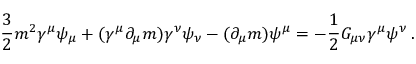<formula> <loc_0><loc_0><loc_500><loc_500>{ \frac { 3 } { 2 } } m ^ { 2 } \gamma ^ { \mu } \psi _ { \mu } + ( \gamma ^ { \mu } \partial _ { \mu } m ) \gamma ^ { \nu } \psi _ { \nu } - ( \partial _ { \mu } m ) \psi ^ { \mu } = - { \frac { 1 } { 2 } } G _ { \mu \nu } \gamma ^ { \mu } \psi ^ { \nu } \, .</formula> 